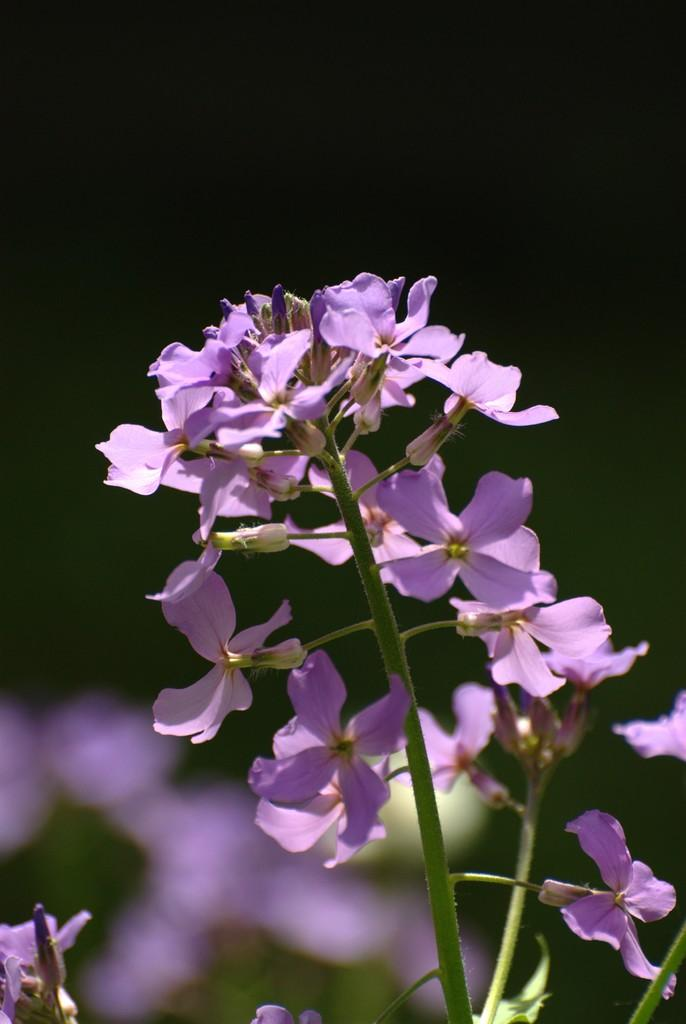What is the main subject of the image? The main subject of the image is a group of flowers. Where are the flowers located in the image? The flowers are on the stems of a plant. What type of cork can be seen in the image? There is no cork present in the image; it features a group of flowers on the stems of a plant. 